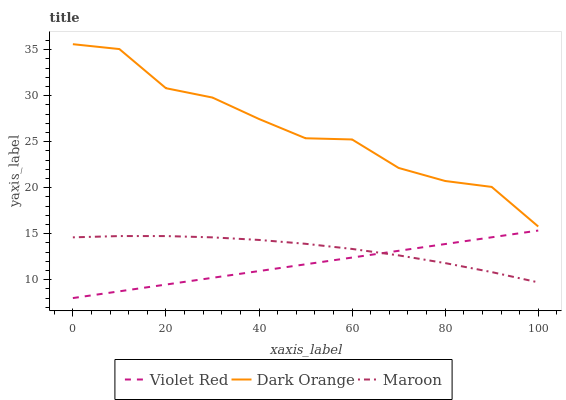Does Violet Red have the minimum area under the curve?
Answer yes or no. Yes. Does Dark Orange have the maximum area under the curve?
Answer yes or no. Yes. Does Maroon have the minimum area under the curve?
Answer yes or no. No. Does Maroon have the maximum area under the curve?
Answer yes or no. No. Is Violet Red the smoothest?
Answer yes or no. Yes. Is Dark Orange the roughest?
Answer yes or no. Yes. Is Maroon the smoothest?
Answer yes or no. No. Is Maroon the roughest?
Answer yes or no. No. Does Violet Red have the lowest value?
Answer yes or no. Yes. Does Maroon have the lowest value?
Answer yes or no. No. Does Dark Orange have the highest value?
Answer yes or no. Yes. Does Violet Red have the highest value?
Answer yes or no. No. Is Violet Red less than Dark Orange?
Answer yes or no. Yes. Is Dark Orange greater than Maroon?
Answer yes or no. Yes. Does Maroon intersect Violet Red?
Answer yes or no. Yes. Is Maroon less than Violet Red?
Answer yes or no. No. Is Maroon greater than Violet Red?
Answer yes or no. No. Does Violet Red intersect Dark Orange?
Answer yes or no. No. 